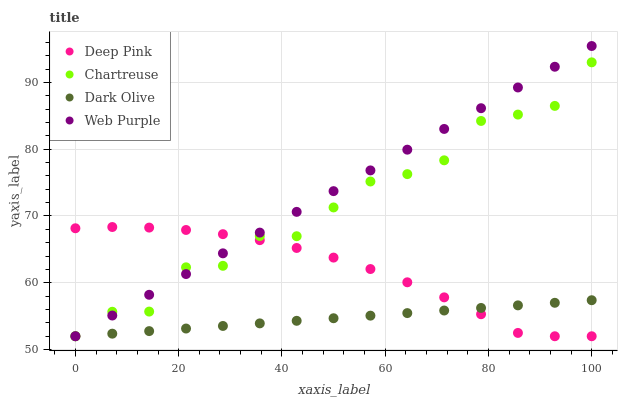Does Dark Olive have the minimum area under the curve?
Answer yes or no. Yes. Does Web Purple have the maximum area under the curve?
Answer yes or no. Yes. Does Chartreuse have the minimum area under the curve?
Answer yes or no. No. Does Chartreuse have the maximum area under the curve?
Answer yes or no. No. Is Web Purple the smoothest?
Answer yes or no. Yes. Is Chartreuse the roughest?
Answer yes or no. Yes. Is Deep Pink the smoothest?
Answer yes or no. No. Is Deep Pink the roughest?
Answer yes or no. No. Does Dark Olive have the lowest value?
Answer yes or no. Yes. Does Web Purple have the highest value?
Answer yes or no. Yes. Does Chartreuse have the highest value?
Answer yes or no. No. Does Chartreuse intersect Web Purple?
Answer yes or no. Yes. Is Chartreuse less than Web Purple?
Answer yes or no. No. Is Chartreuse greater than Web Purple?
Answer yes or no. No. 